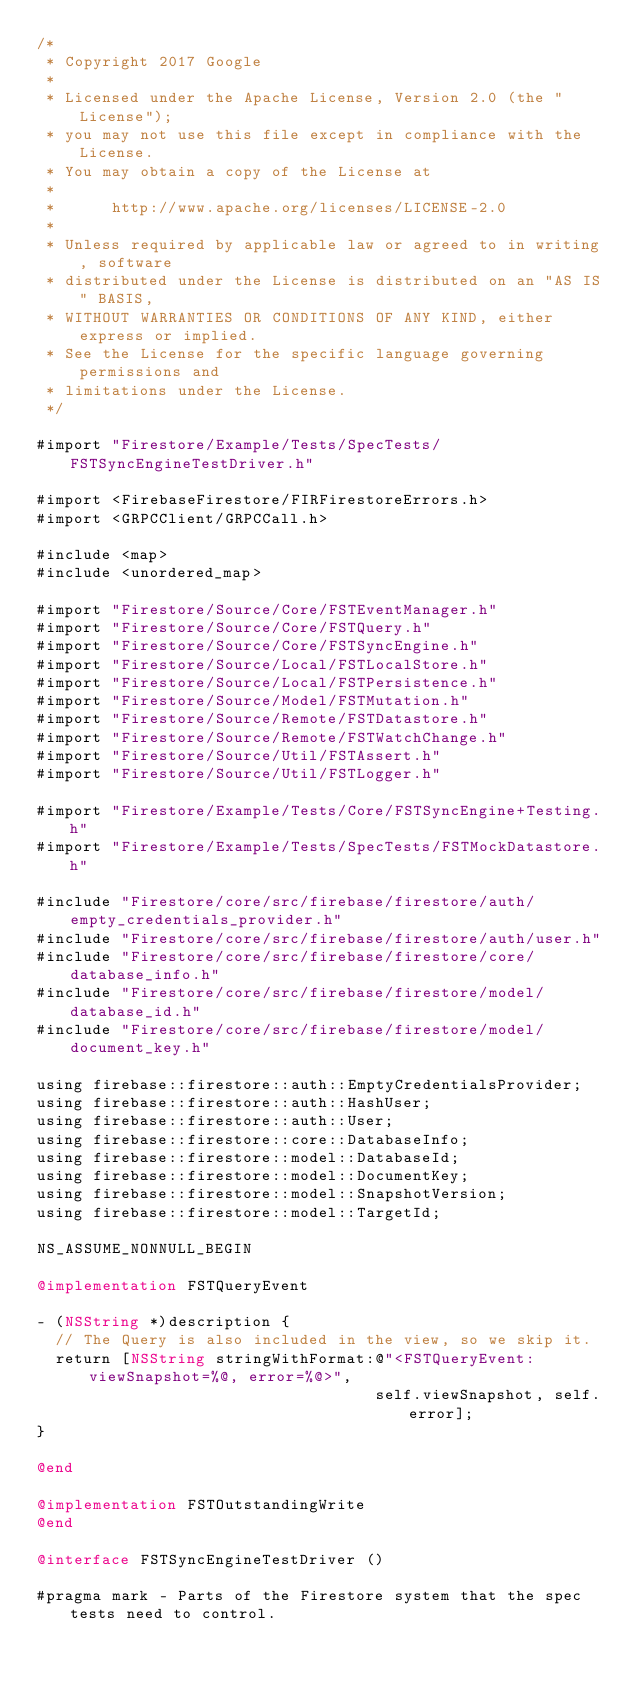Convert code to text. <code><loc_0><loc_0><loc_500><loc_500><_ObjectiveC_>/*
 * Copyright 2017 Google
 *
 * Licensed under the Apache License, Version 2.0 (the "License");
 * you may not use this file except in compliance with the License.
 * You may obtain a copy of the License at
 *
 *      http://www.apache.org/licenses/LICENSE-2.0
 *
 * Unless required by applicable law or agreed to in writing, software
 * distributed under the License is distributed on an "AS IS" BASIS,
 * WITHOUT WARRANTIES OR CONDITIONS OF ANY KIND, either express or implied.
 * See the License for the specific language governing permissions and
 * limitations under the License.
 */

#import "Firestore/Example/Tests/SpecTests/FSTSyncEngineTestDriver.h"

#import <FirebaseFirestore/FIRFirestoreErrors.h>
#import <GRPCClient/GRPCCall.h>

#include <map>
#include <unordered_map>

#import "Firestore/Source/Core/FSTEventManager.h"
#import "Firestore/Source/Core/FSTQuery.h"
#import "Firestore/Source/Core/FSTSyncEngine.h"
#import "Firestore/Source/Local/FSTLocalStore.h"
#import "Firestore/Source/Local/FSTPersistence.h"
#import "Firestore/Source/Model/FSTMutation.h"
#import "Firestore/Source/Remote/FSTDatastore.h"
#import "Firestore/Source/Remote/FSTWatchChange.h"
#import "Firestore/Source/Util/FSTAssert.h"
#import "Firestore/Source/Util/FSTLogger.h"

#import "Firestore/Example/Tests/Core/FSTSyncEngine+Testing.h"
#import "Firestore/Example/Tests/SpecTests/FSTMockDatastore.h"

#include "Firestore/core/src/firebase/firestore/auth/empty_credentials_provider.h"
#include "Firestore/core/src/firebase/firestore/auth/user.h"
#include "Firestore/core/src/firebase/firestore/core/database_info.h"
#include "Firestore/core/src/firebase/firestore/model/database_id.h"
#include "Firestore/core/src/firebase/firestore/model/document_key.h"

using firebase::firestore::auth::EmptyCredentialsProvider;
using firebase::firestore::auth::HashUser;
using firebase::firestore::auth::User;
using firebase::firestore::core::DatabaseInfo;
using firebase::firestore::model::DatabaseId;
using firebase::firestore::model::DocumentKey;
using firebase::firestore::model::SnapshotVersion;
using firebase::firestore::model::TargetId;

NS_ASSUME_NONNULL_BEGIN

@implementation FSTQueryEvent

- (NSString *)description {
  // The Query is also included in the view, so we skip it.
  return [NSString stringWithFormat:@"<FSTQueryEvent: viewSnapshot=%@, error=%@>",
                                    self.viewSnapshot, self.error];
}

@end

@implementation FSTOutstandingWrite
@end

@interface FSTSyncEngineTestDriver ()

#pragma mark - Parts of the Firestore system that the spec tests need to control.
</code> 